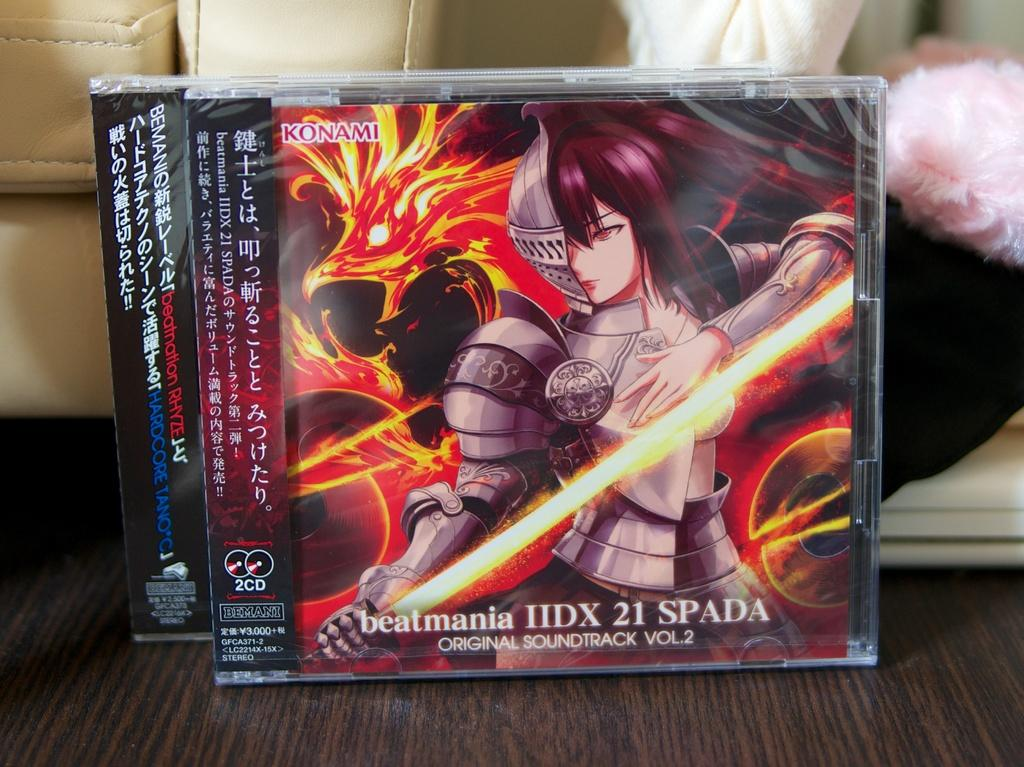<image>
Create a compact narrative representing the image presented. Konami game cases with anime characters on the front. 